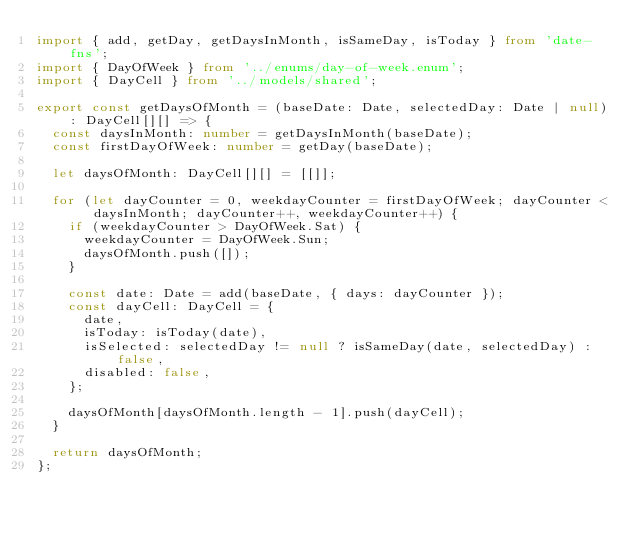Convert code to text. <code><loc_0><loc_0><loc_500><loc_500><_TypeScript_>import { add, getDay, getDaysInMonth, isSameDay, isToday } from 'date-fns';
import { DayOfWeek } from '../enums/day-of-week.enum';
import { DayCell } from '../models/shared';

export const getDaysOfMonth = (baseDate: Date, selectedDay: Date | null): DayCell[][] => {
  const daysInMonth: number = getDaysInMonth(baseDate);
  const firstDayOfWeek: number = getDay(baseDate);

  let daysOfMonth: DayCell[][] = [[]];

  for (let dayCounter = 0, weekdayCounter = firstDayOfWeek; dayCounter < daysInMonth; dayCounter++, weekdayCounter++) {
    if (weekdayCounter > DayOfWeek.Sat) {
      weekdayCounter = DayOfWeek.Sun;
      daysOfMonth.push([]);
    }

    const date: Date = add(baseDate, { days: dayCounter });
    const dayCell: DayCell = {
      date,
      isToday: isToday(date),
      isSelected: selectedDay != null ? isSameDay(date, selectedDay) : false,
      disabled: false,
    };

    daysOfMonth[daysOfMonth.length - 1].push(dayCell);
  }

  return daysOfMonth;
};
</code> 